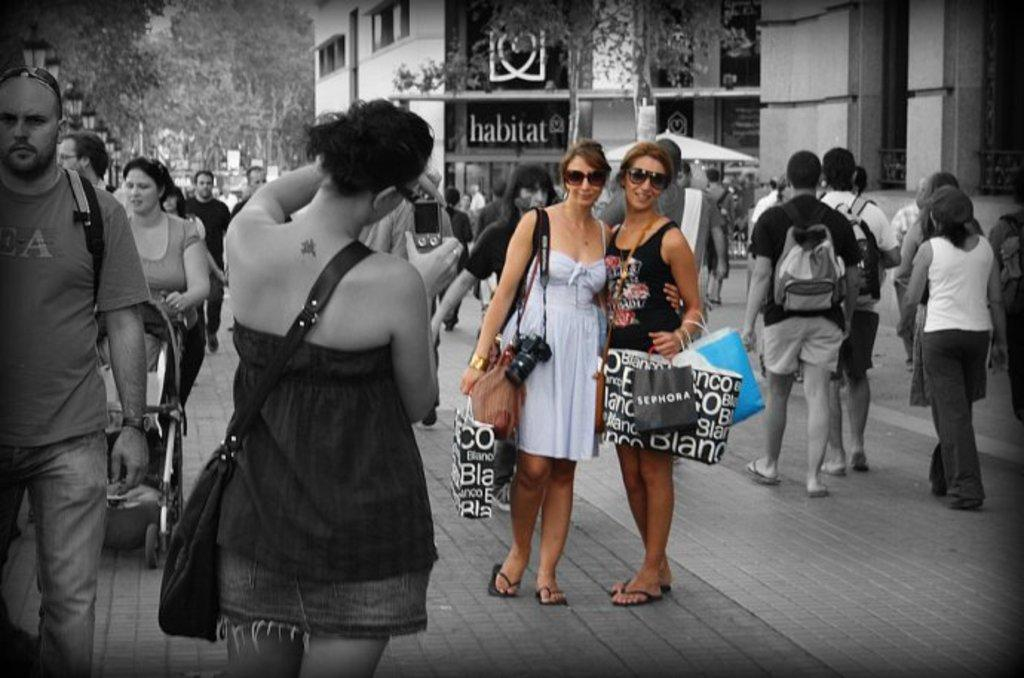How many individuals are present in the image? There are many people in the image. Where are the people located? The people are on a pavement. Can you identify any specific individuals in the image? Two women are highlighted in the image. What can be seen in the background of the image? There is a building in the background of the image. What type of engine is being used by the people in the image? There is no engine present in the image; the people are on a pavement. What reaction can be seen on the faces of the people in the image? The provided facts do not mention any specific reactions on the faces of the people in the image. 